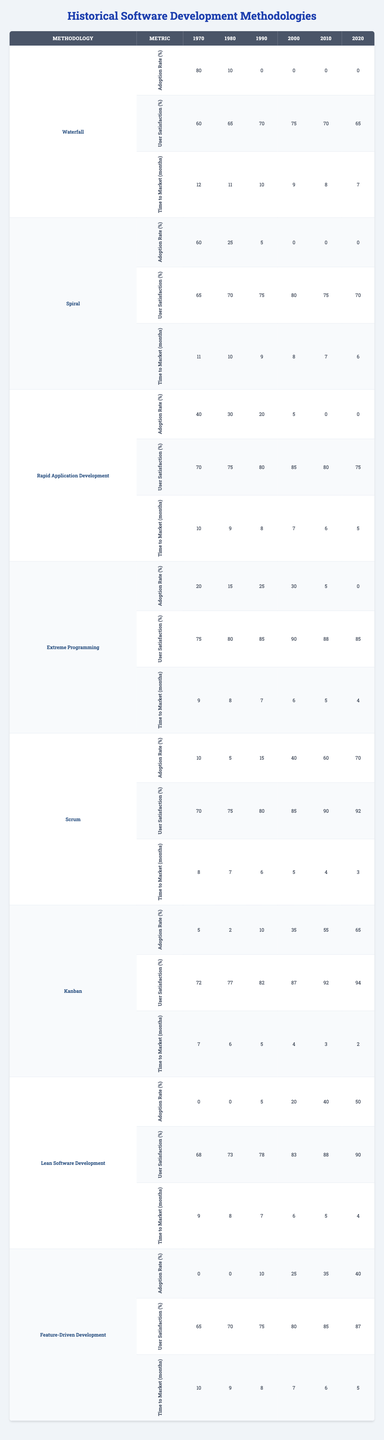What is the highest adoption rate for the Waterfall methodology? In the table, Waterfall’s adoption rates across the years show a peak of 80% in 1970.
Answer: 80% Which methodology had the lowest user satisfaction rate in 2000? The user satisfaction rates for 2000 show that the Spiral methodology had the lowest satisfaction at 70%.
Answer: 70% What is the average time to market for Extreme Programming from 1970 to 2020? The time to market for Extreme Programming over the years is 9, 8, 7, 6, 5, and 4 months. Adding these gives 39, and dividing by 6 gives an average of 6.5 months.
Answer: 6.5 months In which year did Scrum see a 60% adoption rate? Looking at the adoption rates for Scrum, there is a 60% adoption rate observed in 2010.
Answer: 2010 True or False: Lean Software Development had a higher adoption rate in 1990 than in 2000. In 1990, Lean Software Development had a 5% adoption rate, which is lower than the 20% seen in 2000. Therefore, the statement is false.
Answer: False What is the total user satisfaction for Kanban across all observed years? The user satisfaction rates for Kanban are 72, 77, 82, 87, 92, and 94. Summing these gives 504.
Answer: 504 What methodology had the best progression in user satisfaction from 1970 to 2020? By examining the user satisfaction rates, Scrum increased from 70% in 1970 to 92% in 2020, indicating the greatest progression.
Answer: Scrum What is the difference in adoption rates between Feature-Driven Development in 2010 and in 2020? The adoption rates for Feature-Driven Development are 35% in 2010 and 40% in 2020. The difference is 40% - 35% = 5%.
Answer: 5% 